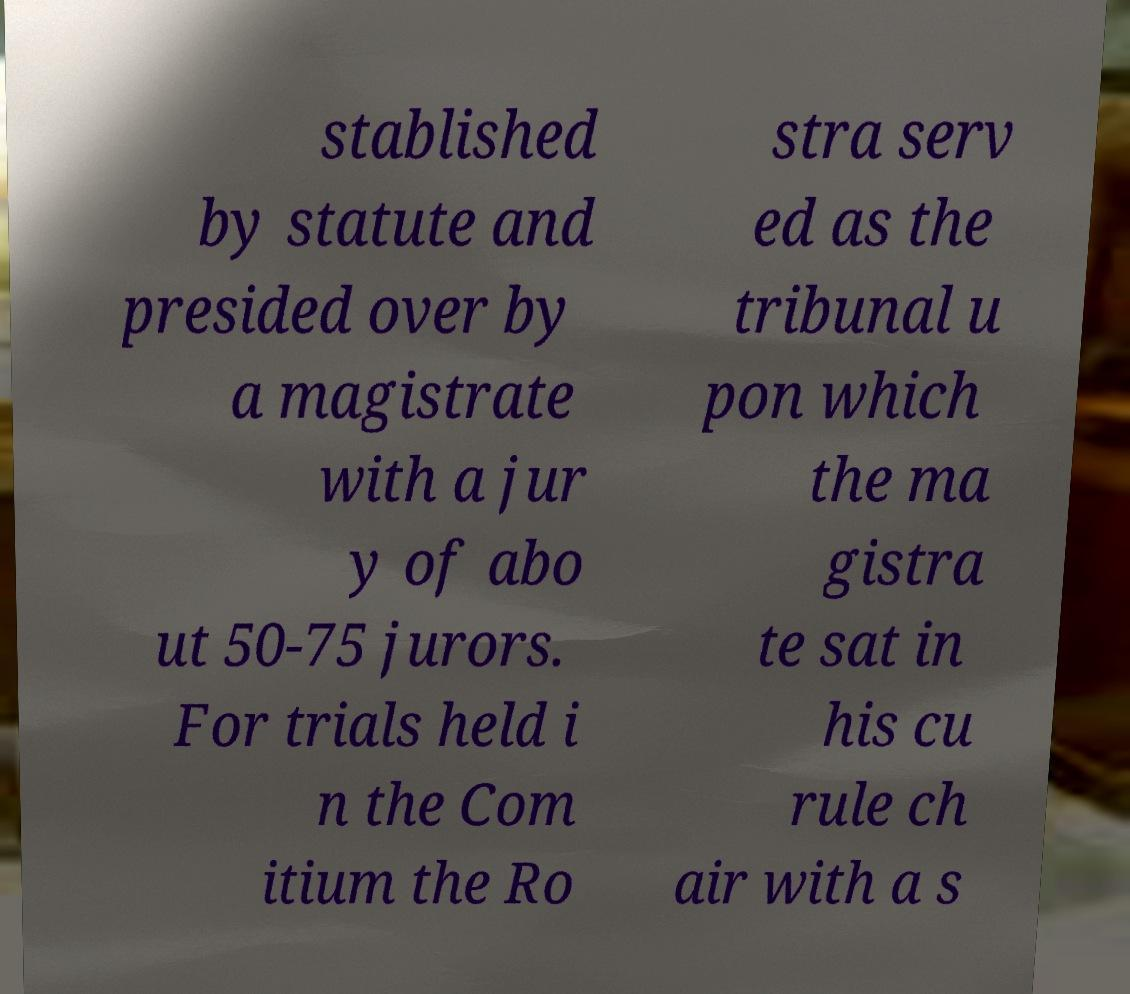For documentation purposes, I need the text within this image transcribed. Could you provide that? stablished by statute and presided over by a magistrate with a jur y of abo ut 50-75 jurors. For trials held i n the Com itium the Ro stra serv ed as the tribunal u pon which the ma gistra te sat in his cu rule ch air with a s 